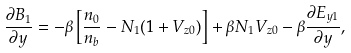Convert formula to latex. <formula><loc_0><loc_0><loc_500><loc_500>\frac { \partial { B _ { 1 } } } { \partial { y } } = - \beta \left [ \frac { n _ { 0 } } { n _ { b } } - N _ { 1 } ( 1 + V _ { z 0 } ) \right ] + { \beta } N _ { 1 } V _ { z 0 } - \beta \frac { \partial { E _ { y 1 } } } { \partial { y } } ,</formula> 